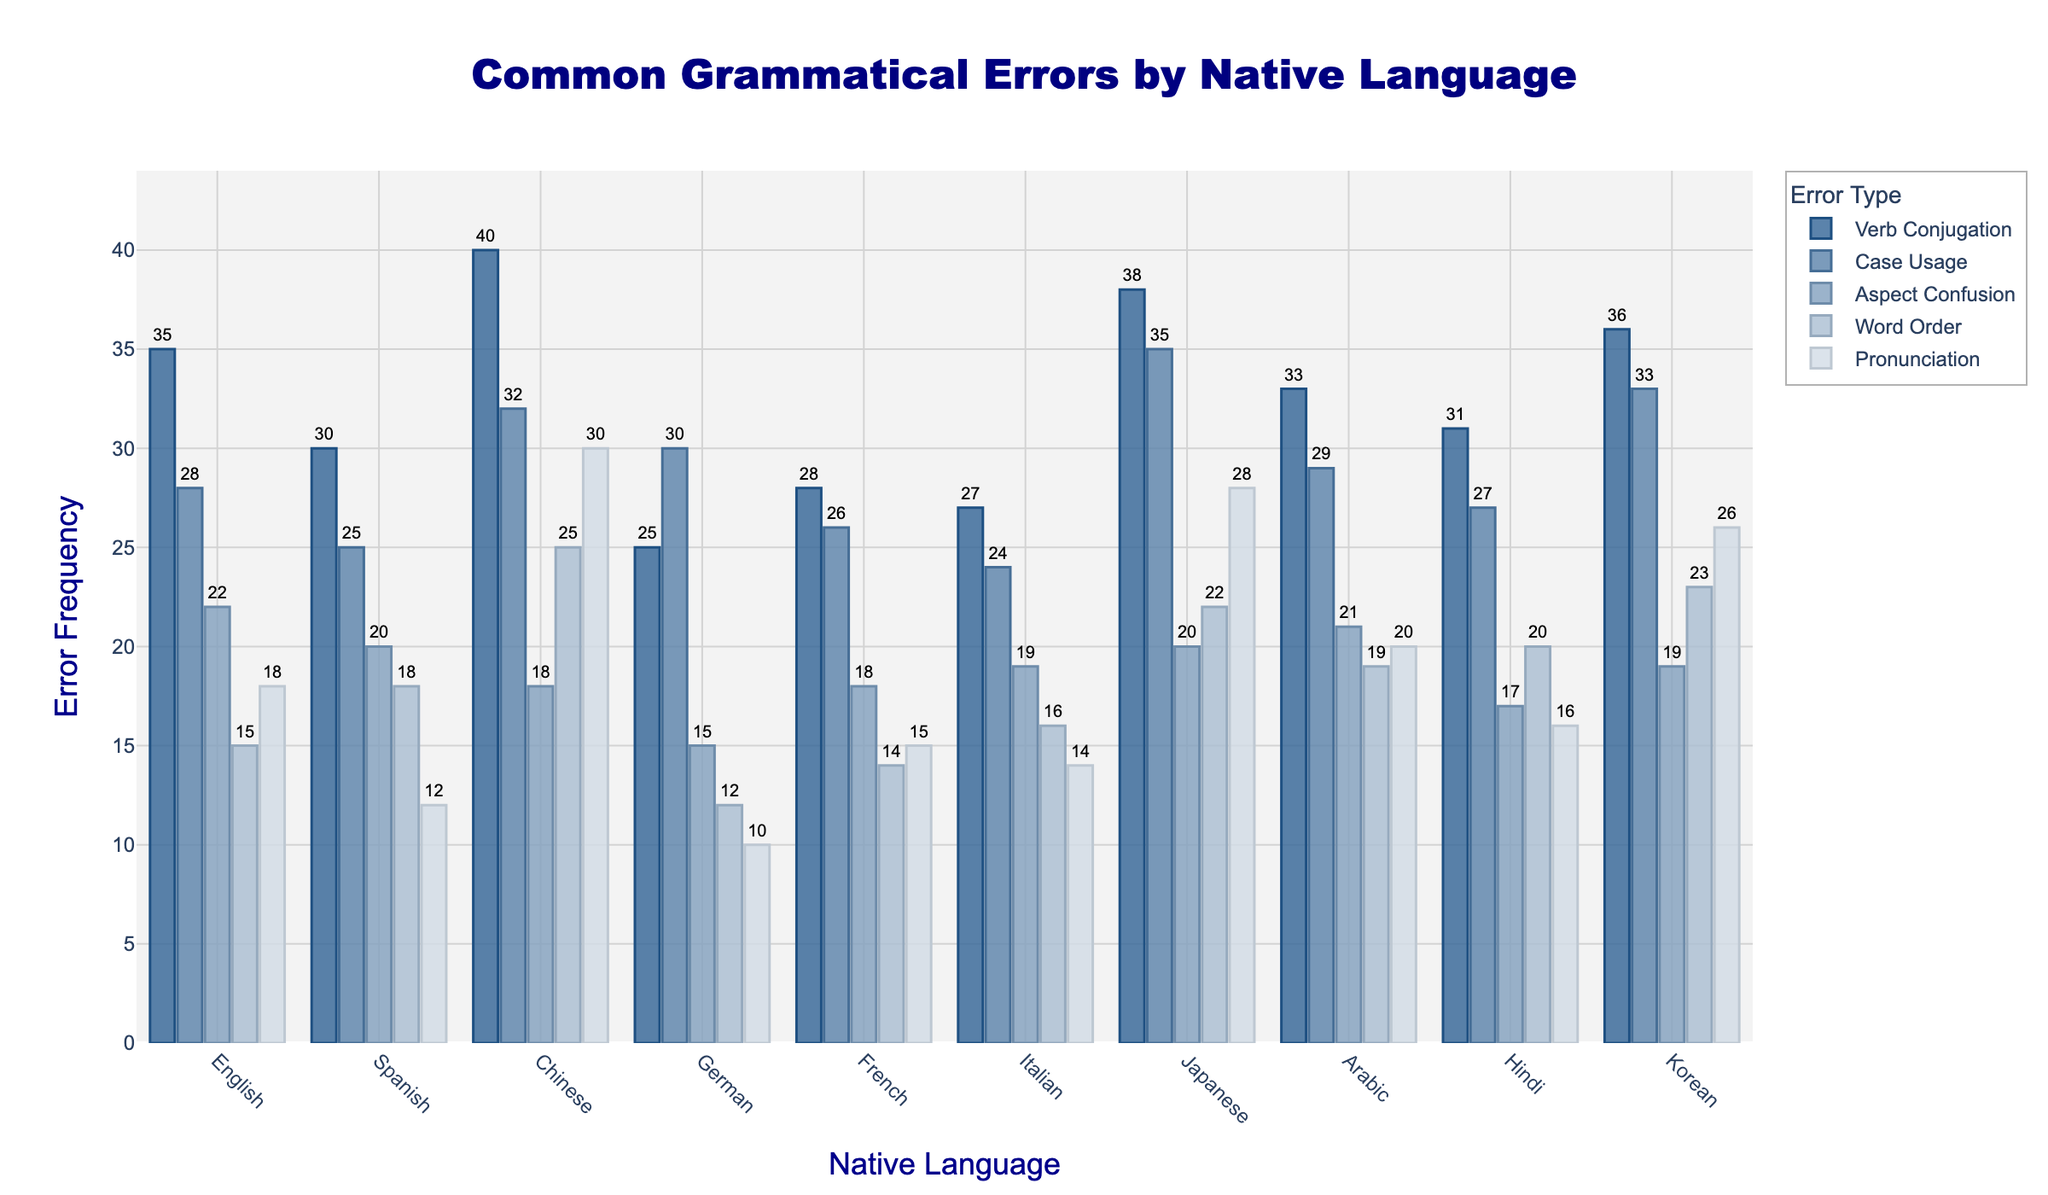What's the title of the plot? Look at the top of the figure to see the main heading.
Answer: Autograph Value Distribution Across Film Genres Which actor has the highest autograph value in the Action genre? Identify the tallest bar in the Action subplot, associated with the actor's name.
Answer: Robert Downey Jr For the Horror genre, what's the range of autograph values? Find the minimum and maximum values of the bars in the Horror subplot and subtract the minimum from the maximum.
Answer: 950 Who has the lowest autograph value in the Sci-Fi genre? Observe the shortest bar in the Sci-Fi subplot and note the actor associated with it.
Answer: Emma Stone What's the average autograph value for Jennifer Lawrence across all genres? Add up Jennifer Lawrence's values from each genre, then divide by the number of genres (5). Calculation: (1000 + 1200 + 1400 + 1100 + 800) / 5
Answer: 1100 Which actor shows the most balanced autograph value across all genres (least variation in bar lengths)? Visually assess which actor's bars have the most similar lengths across all subplots.
Answer: Scarlett Johansson Compare the autograph values of Tom Cruise and Meryl Streep in the Drama genre. Who has the higher value? Look at the bars for Tom Cruise and Meryl Streep in the Drama subplot and see which one is taller.
Answer: Meryl Streep If you combine the autograph values across all genres for Harrison Ford, what is the total? Sum Harrison Ford's values from each genre. Calculation: 1400 + 950 + 1300 + 1600 + 700
Answer: 5950 In the Comedy genre, which two actors have the closest autograph values? Find the two bars in the Comedy subplot that have the smallest difference in length.
Answer: Scarlett Johansson and Emma Stone Which genre exhibits the widest range of autograph values? For each subplot, calculate the difference between the highest and lowest values and then compare these differences across all genres to find the widest range.
Answer: Drama 